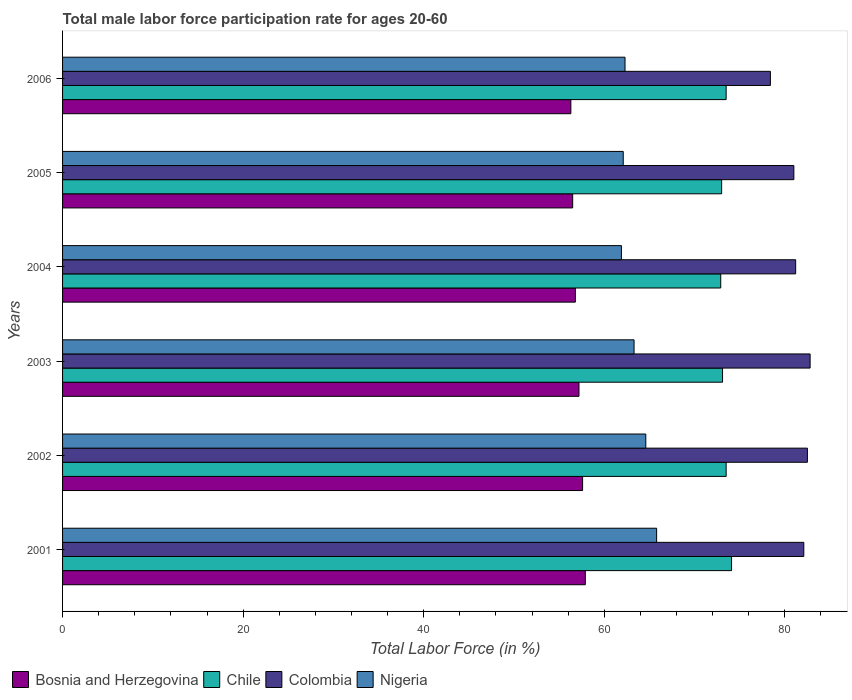How many different coloured bars are there?
Provide a short and direct response. 4. Are the number of bars on each tick of the Y-axis equal?
Give a very brief answer. Yes. How many bars are there on the 5th tick from the bottom?
Make the answer very short. 4. What is the label of the 4th group of bars from the top?
Provide a succinct answer. 2003. In how many cases, is the number of bars for a given year not equal to the number of legend labels?
Your answer should be very brief. 0. What is the male labor force participation rate in Colombia in 2004?
Provide a succinct answer. 81.2. Across all years, what is the maximum male labor force participation rate in Bosnia and Herzegovina?
Your answer should be compact. 57.9. Across all years, what is the minimum male labor force participation rate in Colombia?
Ensure brevity in your answer.  78.4. In which year was the male labor force participation rate in Bosnia and Herzegovina minimum?
Make the answer very short. 2006. What is the total male labor force participation rate in Bosnia and Herzegovina in the graph?
Offer a terse response. 342.3. What is the difference between the male labor force participation rate in Bosnia and Herzegovina in 2004 and that in 2005?
Keep it short and to the point. 0.3. What is the difference between the male labor force participation rate in Colombia in 2005 and the male labor force participation rate in Chile in 2003?
Make the answer very short. 7.9. What is the average male labor force participation rate in Colombia per year?
Give a very brief answer. 81.33. In the year 2002, what is the difference between the male labor force participation rate in Colombia and male labor force participation rate in Nigeria?
Keep it short and to the point. 17.9. What is the ratio of the male labor force participation rate in Chile in 2002 to that in 2006?
Ensure brevity in your answer.  1. Is the difference between the male labor force participation rate in Colombia in 2001 and 2003 greater than the difference between the male labor force participation rate in Nigeria in 2001 and 2003?
Ensure brevity in your answer.  No. What is the difference between the highest and the second highest male labor force participation rate in Nigeria?
Your answer should be compact. 1.2. What is the difference between the highest and the lowest male labor force participation rate in Nigeria?
Offer a terse response. 3.9. In how many years, is the male labor force participation rate in Colombia greater than the average male labor force participation rate in Colombia taken over all years?
Give a very brief answer. 3. Is the sum of the male labor force participation rate in Colombia in 2001 and 2003 greater than the maximum male labor force participation rate in Nigeria across all years?
Your response must be concise. Yes. Is it the case that in every year, the sum of the male labor force participation rate in Bosnia and Herzegovina and male labor force participation rate in Colombia is greater than the sum of male labor force participation rate in Chile and male labor force participation rate in Nigeria?
Give a very brief answer. Yes. What does the 3rd bar from the top in 2001 represents?
Keep it short and to the point. Chile. What does the 2nd bar from the bottom in 2004 represents?
Your response must be concise. Chile. Is it the case that in every year, the sum of the male labor force participation rate in Colombia and male labor force participation rate in Bosnia and Herzegovina is greater than the male labor force participation rate in Nigeria?
Your answer should be compact. Yes. What is the difference between two consecutive major ticks on the X-axis?
Give a very brief answer. 20. Does the graph contain any zero values?
Your answer should be compact. No. Where does the legend appear in the graph?
Give a very brief answer. Bottom left. How many legend labels are there?
Make the answer very short. 4. What is the title of the graph?
Your answer should be compact. Total male labor force participation rate for ages 20-60. What is the label or title of the Y-axis?
Keep it short and to the point. Years. What is the Total Labor Force (in %) in Bosnia and Herzegovina in 2001?
Your answer should be very brief. 57.9. What is the Total Labor Force (in %) in Chile in 2001?
Offer a terse response. 74.1. What is the Total Labor Force (in %) of Colombia in 2001?
Your response must be concise. 82.1. What is the Total Labor Force (in %) of Nigeria in 2001?
Give a very brief answer. 65.8. What is the Total Labor Force (in %) in Bosnia and Herzegovina in 2002?
Offer a very short reply. 57.6. What is the Total Labor Force (in %) in Chile in 2002?
Provide a short and direct response. 73.5. What is the Total Labor Force (in %) in Colombia in 2002?
Give a very brief answer. 82.5. What is the Total Labor Force (in %) of Nigeria in 2002?
Offer a terse response. 64.6. What is the Total Labor Force (in %) of Bosnia and Herzegovina in 2003?
Give a very brief answer. 57.2. What is the Total Labor Force (in %) of Chile in 2003?
Ensure brevity in your answer.  73.1. What is the Total Labor Force (in %) in Colombia in 2003?
Provide a short and direct response. 82.8. What is the Total Labor Force (in %) in Nigeria in 2003?
Provide a succinct answer. 63.3. What is the Total Labor Force (in %) in Bosnia and Herzegovina in 2004?
Make the answer very short. 56.8. What is the Total Labor Force (in %) of Chile in 2004?
Your answer should be compact. 72.9. What is the Total Labor Force (in %) in Colombia in 2004?
Keep it short and to the point. 81.2. What is the Total Labor Force (in %) of Nigeria in 2004?
Provide a short and direct response. 61.9. What is the Total Labor Force (in %) of Bosnia and Herzegovina in 2005?
Your answer should be compact. 56.5. What is the Total Labor Force (in %) in Colombia in 2005?
Offer a terse response. 81. What is the Total Labor Force (in %) in Nigeria in 2005?
Provide a succinct answer. 62.1. What is the Total Labor Force (in %) in Bosnia and Herzegovina in 2006?
Make the answer very short. 56.3. What is the Total Labor Force (in %) in Chile in 2006?
Keep it short and to the point. 73.5. What is the Total Labor Force (in %) in Colombia in 2006?
Offer a terse response. 78.4. What is the Total Labor Force (in %) of Nigeria in 2006?
Ensure brevity in your answer.  62.3. Across all years, what is the maximum Total Labor Force (in %) of Bosnia and Herzegovina?
Provide a short and direct response. 57.9. Across all years, what is the maximum Total Labor Force (in %) of Chile?
Ensure brevity in your answer.  74.1. Across all years, what is the maximum Total Labor Force (in %) of Colombia?
Keep it short and to the point. 82.8. Across all years, what is the maximum Total Labor Force (in %) of Nigeria?
Keep it short and to the point. 65.8. Across all years, what is the minimum Total Labor Force (in %) in Bosnia and Herzegovina?
Your answer should be very brief. 56.3. Across all years, what is the minimum Total Labor Force (in %) of Chile?
Keep it short and to the point. 72.9. Across all years, what is the minimum Total Labor Force (in %) in Colombia?
Your response must be concise. 78.4. Across all years, what is the minimum Total Labor Force (in %) of Nigeria?
Provide a succinct answer. 61.9. What is the total Total Labor Force (in %) in Bosnia and Herzegovina in the graph?
Keep it short and to the point. 342.3. What is the total Total Labor Force (in %) in Chile in the graph?
Offer a very short reply. 440.1. What is the total Total Labor Force (in %) of Colombia in the graph?
Offer a very short reply. 488. What is the total Total Labor Force (in %) in Nigeria in the graph?
Provide a short and direct response. 380. What is the difference between the Total Labor Force (in %) of Colombia in 2001 and that in 2002?
Your answer should be very brief. -0.4. What is the difference between the Total Labor Force (in %) in Nigeria in 2001 and that in 2002?
Your answer should be compact. 1.2. What is the difference between the Total Labor Force (in %) of Bosnia and Herzegovina in 2001 and that in 2003?
Provide a short and direct response. 0.7. What is the difference between the Total Labor Force (in %) in Bosnia and Herzegovina in 2001 and that in 2004?
Your response must be concise. 1.1. What is the difference between the Total Labor Force (in %) of Nigeria in 2001 and that in 2004?
Your response must be concise. 3.9. What is the difference between the Total Labor Force (in %) in Bosnia and Herzegovina in 2001 and that in 2005?
Offer a terse response. 1.4. What is the difference between the Total Labor Force (in %) in Chile in 2001 and that in 2005?
Provide a short and direct response. 1.1. What is the difference between the Total Labor Force (in %) of Nigeria in 2001 and that in 2005?
Ensure brevity in your answer.  3.7. What is the difference between the Total Labor Force (in %) in Bosnia and Herzegovina in 2001 and that in 2006?
Your answer should be very brief. 1.6. What is the difference between the Total Labor Force (in %) of Chile in 2001 and that in 2006?
Your answer should be very brief. 0.6. What is the difference between the Total Labor Force (in %) in Colombia in 2001 and that in 2006?
Your response must be concise. 3.7. What is the difference between the Total Labor Force (in %) in Nigeria in 2001 and that in 2006?
Make the answer very short. 3.5. What is the difference between the Total Labor Force (in %) in Nigeria in 2002 and that in 2003?
Ensure brevity in your answer.  1.3. What is the difference between the Total Labor Force (in %) of Colombia in 2002 and that in 2004?
Offer a very short reply. 1.3. What is the difference between the Total Labor Force (in %) in Bosnia and Herzegovina in 2002 and that in 2005?
Your answer should be very brief. 1.1. What is the difference between the Total Labor Force (in %) of Chile in 2002 and that in 2005?
Provide a short and direct response. 0.5. What is the difference between the Total Labor Force (in %) of Colombia in 2002 and that in 2005?
Offer a very short reply. 1.5. What is the difference between the Total Labor Force (in %) in Nigeria in 2002 and that in 2005?
Your answer should be compact. 2.5. What is the difference between the Total Labor Force (in %) of Colombia in 2002 and that in 2006?
Give a very brief answer. 4.1. What is the difference between the Total Labor Force (in %) of Chile in 2003 and that in 2004?
Your response must be concise. 0.2. What is the difference between the Total Labor Force (in %) of Bosnia and Herzegovina in 2003 and that in 2005?
Ensure brevity in your answer.  0.7. What is the difference between the Total Labor Force (in %) of Chile in 2003 and that in 2005?
Ensure brevity in your answer.  0.1. What is the difference between the Total Labor Force (in %) of Colombia in 2003 and that in 2005?
Offer a terse response. 1.8. What is the difference between the Total Labor Force (in %) in Chile in 2004 and that in 2005?
Your answer should be compact. -0.1. What is the difference between the Total Labor Force (in %) in Nigeria in 2004 and that in 2006?
Provide a succinct answer. -0.4. What is the difference between the Total Labor Force (in %) in Chile in 2005 and that in 2006?
Provide a short and direct response. -0.5. What is the difference between the Total Labor Force (in %) of Colombia in 2005 and that in 2006?
Provide a short and direct response. 2.6. What is the difference between the Total Labor Force (in %) of Nigeria in 2005 and that in 2006?
Provide a short and direct response. -0.2. What is the difference between the Total Labor Force (in %) in Bosnia and Herzegovina in 2001 and the Total Labor Force (in %) in Chile in 2002?
Your response must be concise. -15.6. What is the difference between the Total Labor Force (in %) in Bosnia and Herzegovina in 2001 and the Total Labor Force (in %) in Colombia in 2002?
Your response must be concise. -24.6. What is the difference between the Total Labor Force (in %) in Bosnia and Herzegovina in 2001 and the Total Labor Force (in %) in Nigeria in 2002?
Your answer should be compact. -6.7. What is the difference between the Total Labor Force (in %) in Colombia in 2001 and the Total Labor Force (in %) in Nigeria in 2002?
Keep it short and to the point. 17.5. What is the difference between the Total Labor Force (in %) in Bosnia and Herzegovina in 2001 and the Total Labor Force (in %) in Chile in 2003?
Offer a terse response. -15.2. What is the difference between the Total Labor Force (in %) of Bosnia and Herzegovina in 2001 and the Total Labor Force (in %) of Colombia in 2003?
Your answer should be compact. -24.9. What is the difference between the Total Labor Force (in %) in Bosnia and Herzegovina in 2001 and the Total Labor Force (in %) in Nigeria in 2003?
Ensure brevity in your answer.  -5.4. What is the difference between the Total Labor Force (in %) of Chile in 2001 and the Total Labor Force (in %) of Colombia in 2003?
Your answer should be very brief. -8.7. What is the difference between the Total Labor Force (in %) in Colombia in 2001 and the Total Labor Force (in %) in Nigeria in 2003?
Provide a succinct answer. 18.8. What is the difference between the Total Labor Force (in %) of Bosnia and Herzegovina in 2001 and the Total Labor Force (in %) of Colombia in 2004?
Give a very brief answer. -23.3. What is the difference between the Total Labor Force (in %) of Colombia in 2001 and the Total Labor Force (in %) of Nigeria in 2004?
Your response must be concise. 20.2. What is the difference between the Total Labor Force (in %) of Bosnia and Herzegovina in 2001 and the Total Labor Force (in %) of Chile in 2005?
Keep it short and to the point. -15.1. What is the difference between the Total Labor Force (in %) of Bosnia and Herzegovina in 2001 and the Total Labor Force (in %) of Colombia in 2005?
Provide a short and direct response. -23.1. What is the difference between the Total Labor Force (in %) in Bosnia and Herzegovina in 2001 and the Total Labor Force (in %) in Nigeria in 2005?
Keep it short and to the point. -4.2. What is the difference between the Total Labor Force (in %) of Chile in 2001 and the Total Labor Force (in %) of Nigeria in 2005?
Offer a terse response. 12. What is the difference between the Total Labor Force (in %) in Bosnia and Herzegovina in 2001 and the Total Labor Force (in %) in Chile in 2006?
Your answer should be very brief. -15.6. What is the difference between the Total Labor Force (in %) of Bosnia and Herzegovina in 2001 and the Total Labor Force (in %) of Colombia in 2006?
Offer a very short reply. -20.5. What is the difference between the Total Labor Force (in %) of Bosnia and Herzegovina in 2001 and the Total Labor Force (in %) of Nigeria in 2006?
Your answer should be compact. -4.4. What is the difference between the Total Labor Force (in %) in Chile in 2001 and the Total Labor Force (in %) in Colombia in 2006?
Your answer should be very brief. -4.3. What is the difference between the Total Labor Force (in %) of Colombia in 2001 and the Total Labor Force (in %) of Nigeria in 2006?
Your answer should be compact. 19.8. What is the difference between the Total Labor Force (in %) of Bosnia and Herzegovina in 2002 and the Total Labor Force (in %) of Chile in 2003?
Make the answer very short. -15.5. What is the difference between the Total Labor Force (in %) of Bosnia and Herzegovina in 2002 and the Total Labor Force (in %) of Colombia in 2003?
Provide a succinct answer. -25.2. What is the difference between the Total Labor Force (in %) of Bosnia and Herzegovina in 2002 and the Total Labor Force (in %) of Nigeria in 2003?
Make the answer very short. -5.7. What is the difference between the Total Labor Force (in %) of Chile in 2002 and the Total Labor Force (in %) of Nigeria in 2003?
Offer a very short reply. 10.2. What is the difference between the Total Labor Force (in %) of Colombia in 2002 and the Total Labor Force (in %) of Nigeria in 2003?
Offer a very short reply. 19.2. What is the difference between the Total Labor Force (in %) in Bosnia and Herzegovina in 2002 and the Total Labor Force (in %) in Chile in 2004?
Provide a succinct answer. -15.3. What is the difference between the Total Labor Force (in %) of Bosnia and Herzegovina in 2002 and the Total Labor Force (in %) of Colombia in 2004?
Offer a terse response. -23.6. What is the difference between the Total Labor Force (in %) of Bosnia and Herzegovina in 2002 and the Total Labor Force (in %) of Nigeria in 2004?
Offer a terse response. -4.3. What is the difference between the Total Labor Force (in %) in Chile in 2002 and the Total Labor Force (in %) in Nigeria in 2004?
Give a very brief answer. 11.6. What is the difference between the Total Labor Force (in %) in Colombia in 2002 and the Total Labor Force (in %) in Nigeria in 2004?
Ensure brevity in your answer.  20.6. What is the difference between the Total Labor Force (in %) of Bosnia and Herzegovina in 2002 and the Total Labor Force (in %) of Chile in 2005?
Offer a terse response. -15.4. What is the difference between the Total Labor Force (in %) of Bosnia and Herzegovina in 2002 and the Total Labor Force (in %) of Colombia in 2005?
Make the answer very short. -23.4. What is the difference between the Total Labor Force (in %) in Chile in 2002 and the Total Labor Force (in %) in Colombia in 2005?
Ensure brevity in your answer.  -7.5. What is the difference between the Total Labor Force (in %) of Colombia in 2002 and the Total Labor Force (in %) of Nigeria in 2005?
Provide a short and direct response. 20.4. What is the difference between the Total Labor Force (in %) in Bosnia and Herzegovina in 2002 and the Total Labor Force (in %) in Chile in 2006?
Provide a short and direct response. -15.9. What is the difference between the Total Labor Force (in %) of Bosnia and Herzegovina in 2002 and the Total Labor Force (in %) of Colombia in 2006?
Keep it short and to the point. -20.8. What is the difference between the Total Labor Force (in %) in Bosnia and Herzegovina in 2002 and the Total Labor Force (in %) in Nigeria in 2006?
Your response must be concise. -4.7. What is the difference between the Total Labor Force (in %) of Colombia in 2002 and the Total Labor Force (in %) of Nigeria in 2006?
Ensure brevity in your answer.  20.2. What is the difference between the Total Labor Force (in %) in Bosnia and Herzegovina in 2003 and the Total Labor Force (in %) in Chile in 2004?
Offer a terse response. -15.7. What is the difference between the Total Labor Force (in %) of Colombia in 2003 and the Total Labor Force (in %) of Nigeria in 2004?
Your response must be concise. 20.9. What is the difference between the Total Labor Force (in %) in Bosnia and Herzegovina in 2003 and the Total Labor Force (in %) in Chile in 2005?
Offer a terse response. -15.8. What is the difference between the Total Labor Force (in %) of Bosnia and Herzegovina in 2003 and the Total Labor Force (in %) of Colombia in 2005?
Your answer should be compact. -23.8. What is the difference between the Total Labor Force (in %) of Bosnia and Herzegovina in 2003 and the Total Labor Force (in %) of Nigeria in 2005?
Your response must be concise. -4.9. What is the difference between the Total Labor Force (in %) of Chile in 2003 and the Total Labor Force (in %) of Colombia in 2005?
Your response must be concise. -7.9. What is the difference between the Total Labor Force (in %) of Chile in 2003 and the Total Labor Force (in %) of Nigeria in 2005?
Provide a short and direct response. 11. What is the difference between the Total Labor Force (in %) of Colombia in 2003 and the Total Labor Force (in %) of Nigeria in 2005?
Make the answer very short. 20.7. What is the difference between the Total Labor Force (in %) of Bosnia and Herzegovina in 2003 and the Total Labor Force (in %) of Chile in 2006?
Ensure brevity in your answer.  -16.3. What is the difference between the Total Labor Force (in %) in Bosnia and Herzegovina in 2003 and the Total Labor Force (in %) in Colombia in 2006?
Make the answer very short. -21.2. What is the difference between the Total Labor Force (in %) in Bosnia and Herzegovina in 2003 and the Total Labor Force (in %) in Nigeria in 2006?
Your answer should be compact. -5.1. What is the difference between the Total Labor Force (in %) of Chile in 2003 and the Total Labor Force (in %) of Colombia in 2006?
Provide a short and direct response. -5.3. What is the difference between the Total Labor Force (in %) in Chile in 2003 and the Total Labor Force (in %) in Nigeria in 2006?
Offer a terse response. 10.8. What is the difference between the Total Labor Force (in %) of Colombia in 2003 and the Total Labor Force (in %) of Nigeria in 2006?
Your answer should be very brief. 20.5. What is the difference between the Total Labor Force (in %) in Bosnia and Herzegovina in 2004 and the Total Labor Force (in %) in Chile in 2005?
Offer a very short reply. -16.2. What is the difference between the Total Labor Force (in %) in Bosnia and Herzegovina in 2004 and the Total Labor Force (in %) in Colombia in 2005?
Your answer should be very brief. -24.2. What is the difference between the Total Labor Force (in %) of Bosnia and Herzegovina in 2004 and the Total Labor Force (in %) of Nigeria in 2005?
Make the answer very short. -5.3. What is the difference between the Total Labor Force (in %) in Bosnia and Herzegovina in 2004 and the Total Labor Force (in %) in Chile in 2006?
Your response must be concise. -16.7. What is the difference between the Total Labor Force (in %) of Bosnia and Herzegovina in 2004 and the Total Labor Force (in %) of Colombia in 2006?
Your answer should be compact. -21.6. What is the difference between the Total Labor Force (in %) of Bosnia and Herzegovina in 2004 and the Total Labor Force (in %) of Nigeria in 2006?
Offer a terse response. -5.5. What is the difference between the Total Labor Force (in %) of Chile in 2004 and the Total Labor Force (in %) of Nigeria in 2006?
Give a very brief answer. 10.6. What is the difference between the Total Labor Force (in %) of Colombia in 2004 and the Total Labor Force (in %) of Nigeria in 2006?
Provide a short and direct response. 18.9. What is the difference between the Total Labor Force (in %) in Bosnia and Herzegovina in 2005 and the Total Labor Force (in %) in Chile in 2006?
Provide a succinct answer. -17. What is the difference between the Total Labor Force (in %) in Bosnia and Herzegovina in 2005 and the Total Labor Force (in %) in Colombia in 2006?
Your answer should be compact. -21.9. What is the difference between the Total Labor Force (in %) in Chile in 2005 and the Total Labor Force (in %) in Colombia in 2006?
Provide a succinct answer. -5.4. What is the difference between the Total Labor Force (in %) in Chile in 2005 and the Total Labor Force (in %) in Nigeria in 2006?
Ensure brevity in your answer.  10.7. What is the difference between the Total Labor Force (in %) in Colombia in 2005 and the Total Labor Force (in %) in Nigeria in 2006?
Give a very brief answer. 18.7. What is the average Total Labor Force (in %) in Bosnia and Herzegovina per year?
Your answer should be very brief. 57.05. What is the average Total Labor Force (in %) of Chile per year?
Keep it short and to the point. 73.35. What is the average Total Labor Force (in %) of Colombia per year?
Keep it short and to the point. 81.33. What is the average Total Labor Force (in %) of Nigeria per year?
Offer a terse response. 63.33. In the year 2001, what is the difference between the Total Labor Force (in %) of Bosnia and Herzegovina and Total Labor Force (in %) of Chile?
Offer a terse response. -16.2. In the year 2001, what is the difference between the Total Labor Force (in %) in Bosnia and Herzegovina and Total Labor Force (in %) in Colombia?
Give a very brief answer. -24.2. In the year 2002, what is the difference between the Total Labor Force (in %) of Bosnia and Herzegovina and Total Labor Force (in %) of Chile?
Your answer should be very brief. -15.9. In the year 2002, what is the difference between the Total Labor Force (in %) in Bosnia and Herzegovina and Total Labor Force (in %) in Colombia?
Your answer should be compact. -24.9. In the year 2002, what is the difference between the Total Labor Force (in %) in Bosnia and Herzegovina and Total Labor Force (in %) in Nigeria?
Your answer should be compact. -7. In the year 2002, what is the difference between the Total Labor Force (in %) of Chile and Total Labor Force (in %) of Colombia?
Offer a terse response. -9. In the year 2003, what is the difference between the Total Labor Force (in %) of Bosnia and Herzegovina and Total Labor Force (in %) of Chile?
Your answer should be compact. -15.9. In the year 2003, what is the difference between the Total Labor Force (in %) of Bosnia and Herzegovina and Total Labor Force (in %) of Colombia?
Provide a short and direct response. -25.6. In the year 2004, what is the difference between the Total Labor Force (in %) of Bosnia and Herzegovina and Total Labor Force (in %) of Chile?
Give a very brief answer. -16.1. In the year 2004, what is the difference between the Total Labor Force (in %) in Bosnia and Herzegovina and Total Labor Force (in %) in Colombia?
Your answer should be compact. -24.4. In the year 2004, what is the difference between the Total Labor Force (in %) of Bosnia and Herzegovina and Total Labor Force (in %) of Nigeria?
Your answer should be compact. -5.1. In the year 2004, what is the difference between the Total Labor Force (in %) of Chile and Total Labor Force (in %) of Colombia?
Ensure brevity in your answer.  -8.3. In the year 2004, what is the difference between the Total Labor Force (in %) of Colombia and Total Labor Force (in %) of Nigeria?
Your response must be concise. 19.3. In the year 2005, what is the difference between the Total Labor Force (in %) in Bosnia and Herzegovina and Total Labor Force (in %) in Chile?
Offer a very short reply. -16.5. In the year 2005, what is the difference between the Total Labor Force (in %) of Bosnia and Herzegovina and Total Labor Force (in %) of Colombia?
Offer a very short reply. -24.5. In the year 2005, what is the difference between the Total Labor Force (in %) of Bosnia and Herzegovina and Total Labor Force (in %) of Nigeria?
Make the answer very short. -5.6. In the year 2005, what is the difference between the Total Labor Force (in %) of Chile and Total Labor Force (in %) of Nigeria?
Provide a succinct answer. 10.9. In the year 2005, what is the difference between the Total Labor Force (in %) in Colombia and Total Labor Force (in %) in Nigeria?
Your answer should be compact. 18.9. In the year 2006, what is the difference between the Total Labor Force (in %) of Bosnia and Herzegovina and Total Labor Force (in %) of Chile?
Make the answer very short. -17.2. In the year 2006, what is the difference between the Total Labor Force (in %) of Bosnia and Herzegovina and Total Labor Force (in %) of Colombia?
Keep it short and to the point. -22.1. In the year 2006, what is the difference between the Total Labor Force (in %) of Bosnia and Herzegovina and Total Labor Force (in %) of Nigeria?
Your response must be concise. -6. In the year 2006, what is the difference between the Total Labor Force (in %) of Chile and Total Labor Force (in %) of Colombia?
Give a very brief answer. -4.9. In the year 2006, what is the difference between the Total Labor Force (in %) of Chile and Total Labor Force (in %) of Nigeria?
Ensure brevity in your answer.  11.2. What is the ratio of the Total Labor Force (in %) of Bosnia and Herzegovina in 2001 to that in 2002?
Your response must be concise. 1.01. What is the ratio of the Total Labor Force (in %) of Chile in 2001 to that in 2002?
Your answer should be compact. 1.01. What is the ratio of the Total Labor Force (in %) in Colombia in 2001 to that in 2002?
Give a very brief answer. 1. What is the ratio of the Total Labor Force (in %) of Nigeria in 2001 to that in 2002?
Offer a terse response. 1.02. What is the ratio of the Total Labor Force (in %) in Bosnia and Herzegovina in 2001 to that in 2003?
Your answer should be very brief. 1.01. What is the ratio of the Total Labor Force (in %) of Chile in 2001 to that in 2003?
Make the answer very short. 1.01. What is the ratio of the Total Labor Force (in %) of Colombia in 2001 to that in 2003?
Your answer should be very brief. 0.99. What is the ratio of the Total Labor Force (in %) of Nigeria in 2001 to that in 2003?
Your response must be concise. 1.04. What is the ratio of the Total Labor Force (in %) of Bosnia and Herzegovina in 2001 to that in 2004?
Make the answer very short. 1.02. What is the ratio of the Total Labor Force (in %) in Chile in 2001 to that in 2004?
Give a very brief answer. 1.02. What is the ratio of the Total Labor Force (in %) in Colombia in 2001 to that in 2004?
Ensure brevity in your answer.  1.01. What is the ratio of the Total Labor Force (in %) in Nigeria in 2001 to that in 2004?
Offer a terse response. 1.06. What is the ratio of the Total Labor Force (in %) of Bosnia and Herzegovina in 2001 to that in 2005?
Give a very brief answer. 1.02. What is the ratio of the Total Labor Force (in %) of Chile in 2001 to that in 2005?
Provide a succinct answer. 1.02. What is the ratio of the Total Labor Force (in %) in Colombia in 2001 to that in 2005?
Your answer should be compact. 1.01. What is the ratio of the Total Labor Force (in %) in Nigeria in 2001 to that in 2005?
Offer a terse response. 1.06. What is the ratio of the Total Labor Force (in %) in Bosnia and Herzegovina in 2001 to that in 2006?
Make the answer very short. 1.03. What is the ratio of the Total Labor Force (in %) in Chile in 2001 to that in 2006?
Ensure brevity in your answer.  1.01. What is the ratio of the Total Labor Force (in %) in Colombia in 2001 to that in 2006?
Your response must be concise. 1.05. What is the ratio of the Total Labor Force (in %) in Nigeria in 2001 to that in 2006?
Give a very brief answer. 1.06. What is the ratio of the Total Labor Force (in %) in Nigeria in 2002 to that in 2003?
Provide a short and direct response. 1.02. What is the ratio of the Total Labor Force (in %) of Bosnia and Herzegovina in 2002 to that in 2004?
Your answer should be compact. 1.01. What is the ratio of the Total Labor Force (in %) of Chile in 2002 to that in 2004?
Ensure brevity in your answer.  1.01. What is the ratio of the Total Labor Force (in %) of Colombia in 2002 to that in 2004?
Offer a terse response. 1.02. What is the ratio of the Total Labor Force (in %) of Nigeria in 2002 to that in 2004?
Ensure brevity in your answer.  1.04. What is the ratio of the Total Labor Force (in %) of Bosnia and Herzegovina in 2002 to that in 2005?
Your answer should be compact. 1.02. What is the ratio of the Total Labor Force (in %) in Chile in 2002 to that in 2005?
Provide a short and direct response. 1.01. What is the ratio of the Total Labor Force (in %) in Colombia in 2002 to that in 2005?
Offer a terse response. 1.02. What is the ratio of the Total Labor Force (in %) in Nigeria in 2002 to that in 2005?
Your response must be concise. 1.04. What is the ratio of the Total Labor Force (in %) in Bosnia and Herzegovina in 2002 to that in 2006?
Your response must be concise. 1.02. What is the ratio of the Total Labor Force (in %) of Colombia in 2002 to that in 2006?
Keep it short and to the point. 1.05. What is the ratio of the Total Labor Force (in %) in Nigeria in 2002 to that in 2006?
Provide a short and direct response. 1.04. What is the ratio of the Total Labor Force (in %) of Bosnia and Herzegovina in 2003 to that in 2004?
Keep it short and to the point. 1.01. What is the ratio of the Total Labor Force (in %) of Colombia in 2003 to that in 2004?
Offer a terse response. 1.02. What is the ratio of the Total Labor Force (in %) of Nigeria in 2003 to that in 2004?
Offer a very short reply. 1.02. What is the ratio of the Total Labor Force (in %) in Bosnia and Herzegovina in 2003 to that in 2005?
Offer a terse response. 1.01. What is the ratio of the Total Labor Force (in %) in Colombia in 2003 to that in 2005?
Ensure brevity in your answer.  1.02. What is the ratio of the Total Labor Force (in %) in Nigeria in 2003 to that in 2005?
Ensure brevity in your answer.  1.02. What is the ratio of the Total Labor Force (in %) of Colombia in 2003 to that in 2006?
Your answer should be compact. 1.06. What is the ratio of the Total Labor Force (in %) of Nigeria in 2003 to that in 2006?
Your answer should be very brief. 1.02. What is the ratio of the Total Labor Force (in %) in Bosnia and Herzegovina in 2004 to that in 2005?
Offer a terse response. 1.01. What is the ratio of the Total Labor Force (in %) of Nigeria in 2004 to that in 2005?
Your answer should be very brief. 1. What is the ratio of the Total Labor Force (in %) in Bosnia and Herzegovina in 2004 to that in 2006?
Your response must be concise. 1.01. What is the ratio of the Total Labor Force (in %) in Chile in 2004 to that in 2006?
Your answer should be compact. 0.99. What is the ratio of the Total Labor Force (in %) of Colombia in 2004 to that in 2006?
Keep it short and to the point. 1.04. What is the ratio of the Total Labor Force (in %) in Bosnia and Herzegovina in 2005 to that in 2006?
Offer a very short reply. 1. What is the ratio of the Total Labor Force (in %) of Colombia in 2005 to that in 2006?
Provide a short and direct response. 1.03. What is the difference between the highest and the second highest Total Labor Force (in %) of Colombia?
Your response must be concise. 0.3. What is the difference between the highest and the lowest Total Labor Force (in %) of Bosnia and Herzegovina?
Your response must be concise. 1.6. 